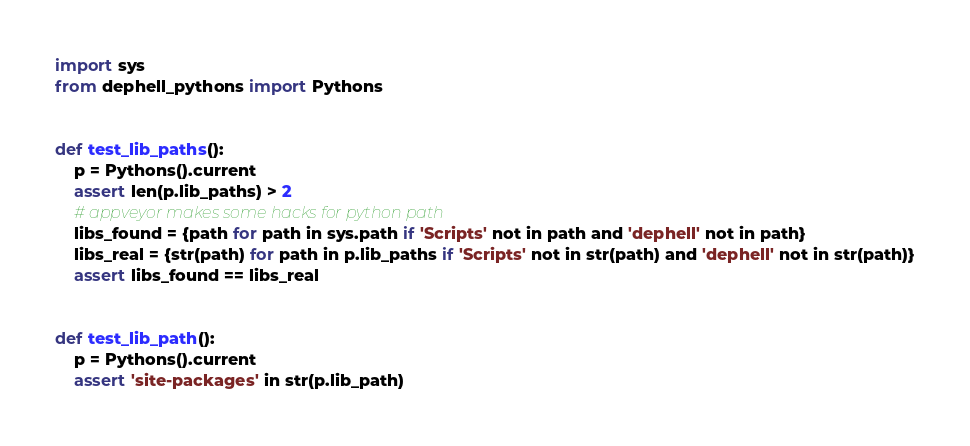Convert code to text. <code><loc_0><loc_0><loc_500><loc_500><_Python_>import sys
from dephell_pythons import Pythons


def test_lib_paths():
    p = Pythons().current
    assert len(p.lib_paths) > 2
    # appveyor makes some hacks for python path
    libs_found = {path for path in sys.path if 'Scripts' not in path and 'dephell' not in path}
    libs_real = {str(path) for path in p.lib_paths if 'Scripts' not in str(path) and 'dephell' not in str(path)}
    assert libs_found == libs_real


def test_lib_path():
    p = Pythons().current
    assert 'site-packages' in str(p.lib_path)
</code> 